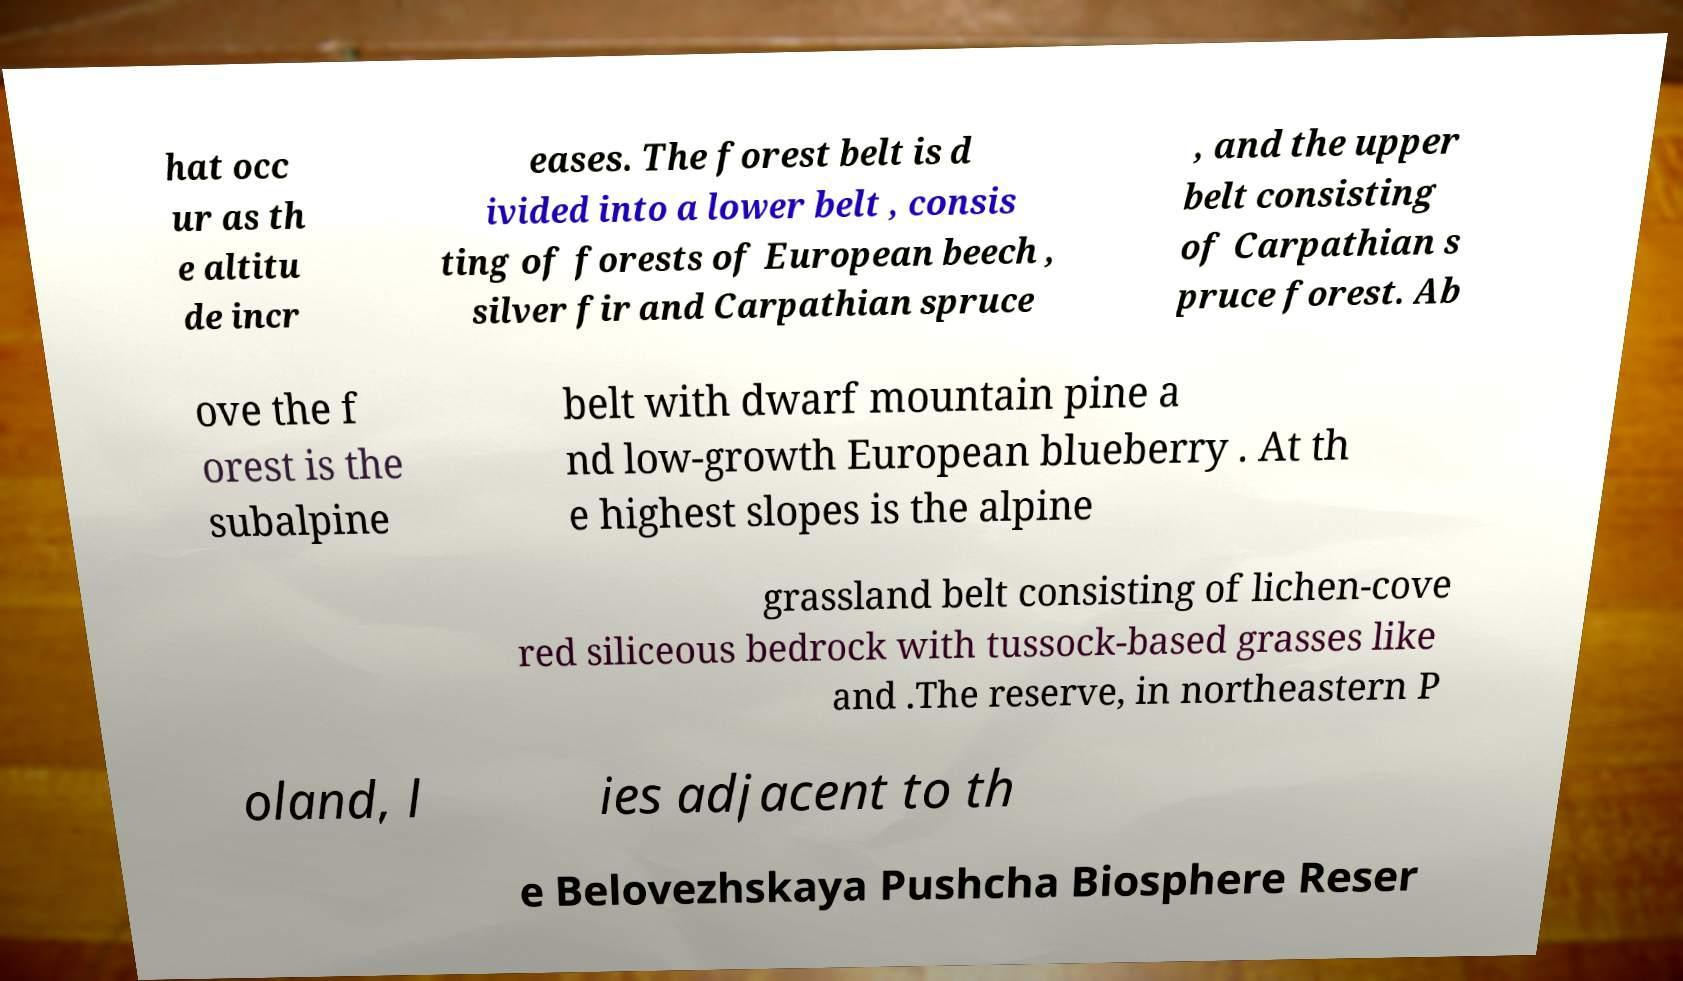What messages or text are displayed in this image? I need them in a readable, typed format. hat occ ur as th e altitu de incr eases. The forest belt is d ivided into a lower belt , consis ting of forests of European beech , silver fir and Carpathian spruce , and the upper belt consisting of Carpathian s pruce forest. Ab ove the f orest is the subalpine belt with dwarf mountain pine a nd low-growth European blueberry . At th e highest slopes is the alpine grassland belt consisting of lichen-cove red siliceous bedrock with tussock-based grasses like and .The reserve, in northeastern P oland, l ies adjacent to th e Belovezhskaya Pushcha Biosphere Reser 